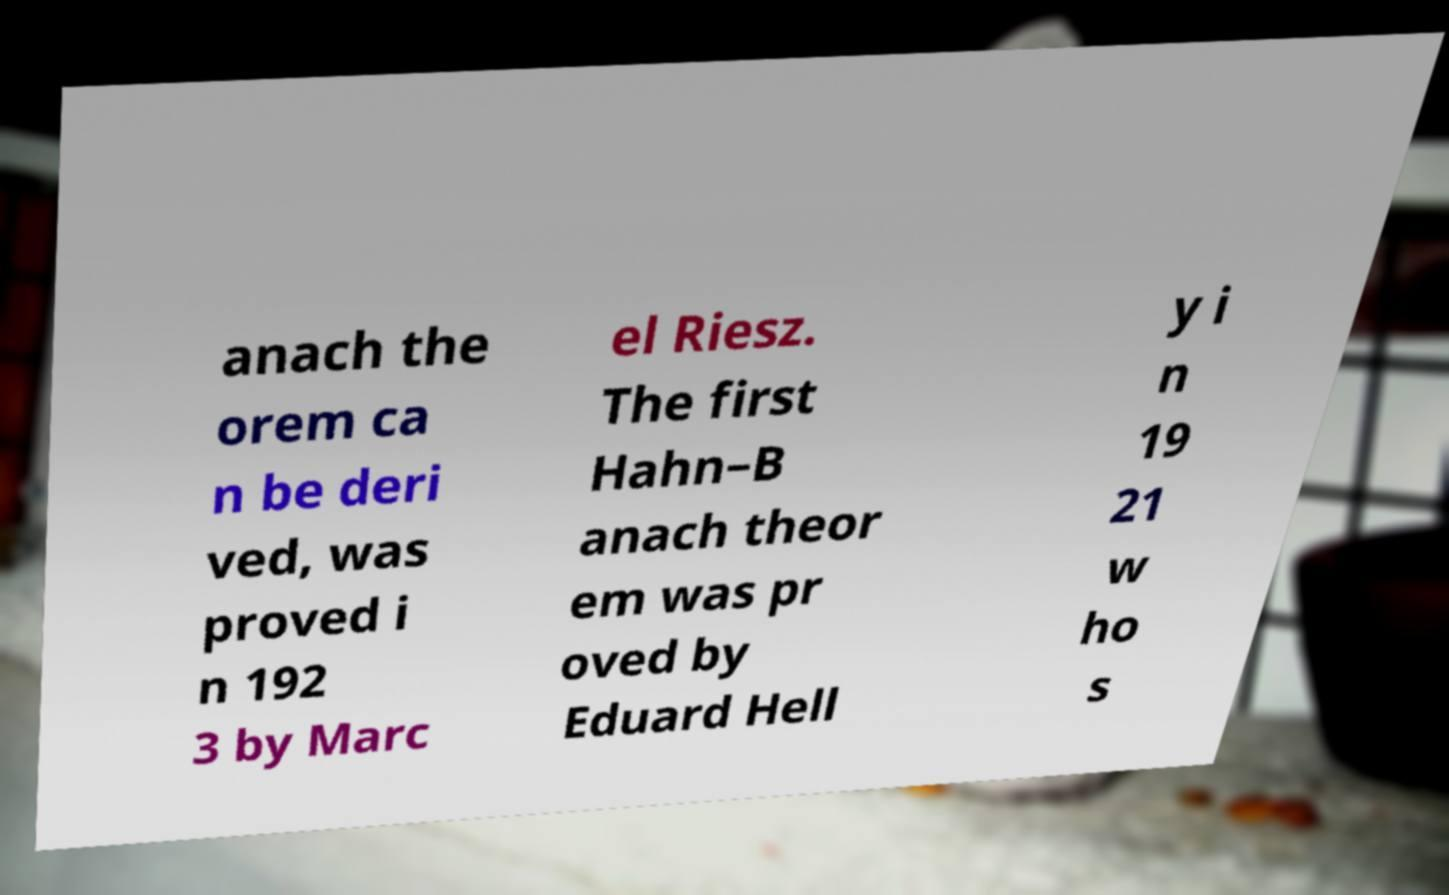Can you accurately transcribe the text from the provided image for me? anach the orem ca n be deri ved, was proved i n 192 3 by Marc el Riesz. The first Hahn–B anach theor em was pr oved by Eduard Hell y i n 19 21 w ho s 